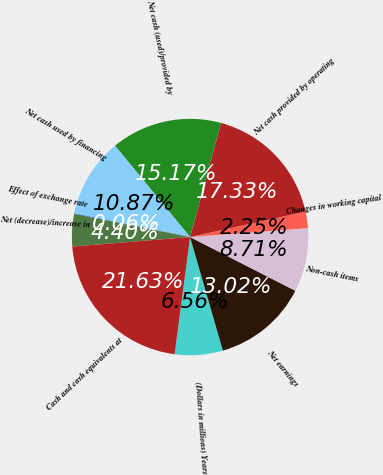Convert chart to OTSL. <chart><loc_0><loc_0><loc_500><loc_500><pie_chart><fcel>(Dollars in millions) Years<fcel>Net earnings<fcel>Non-cash items<fcel>Changes in working capital<fcel>Net cash provided by operating<fcel>Net cash (used)/provided by<fcel>Net cash used by financing<fcel>Effect of exchange rate<fcel>Net (decrease)/increase in<fcel>Cash and cash equivalents at<nl><fcel>6.56%<fcel>13.02%<fcel>8.71%<fcel>2.25%<fcel>17.33%<fcel>15.17%<fcel>10.87%<fcel>0.06%<fcel>4.4%<fcel>21.63%<nl></chart> 